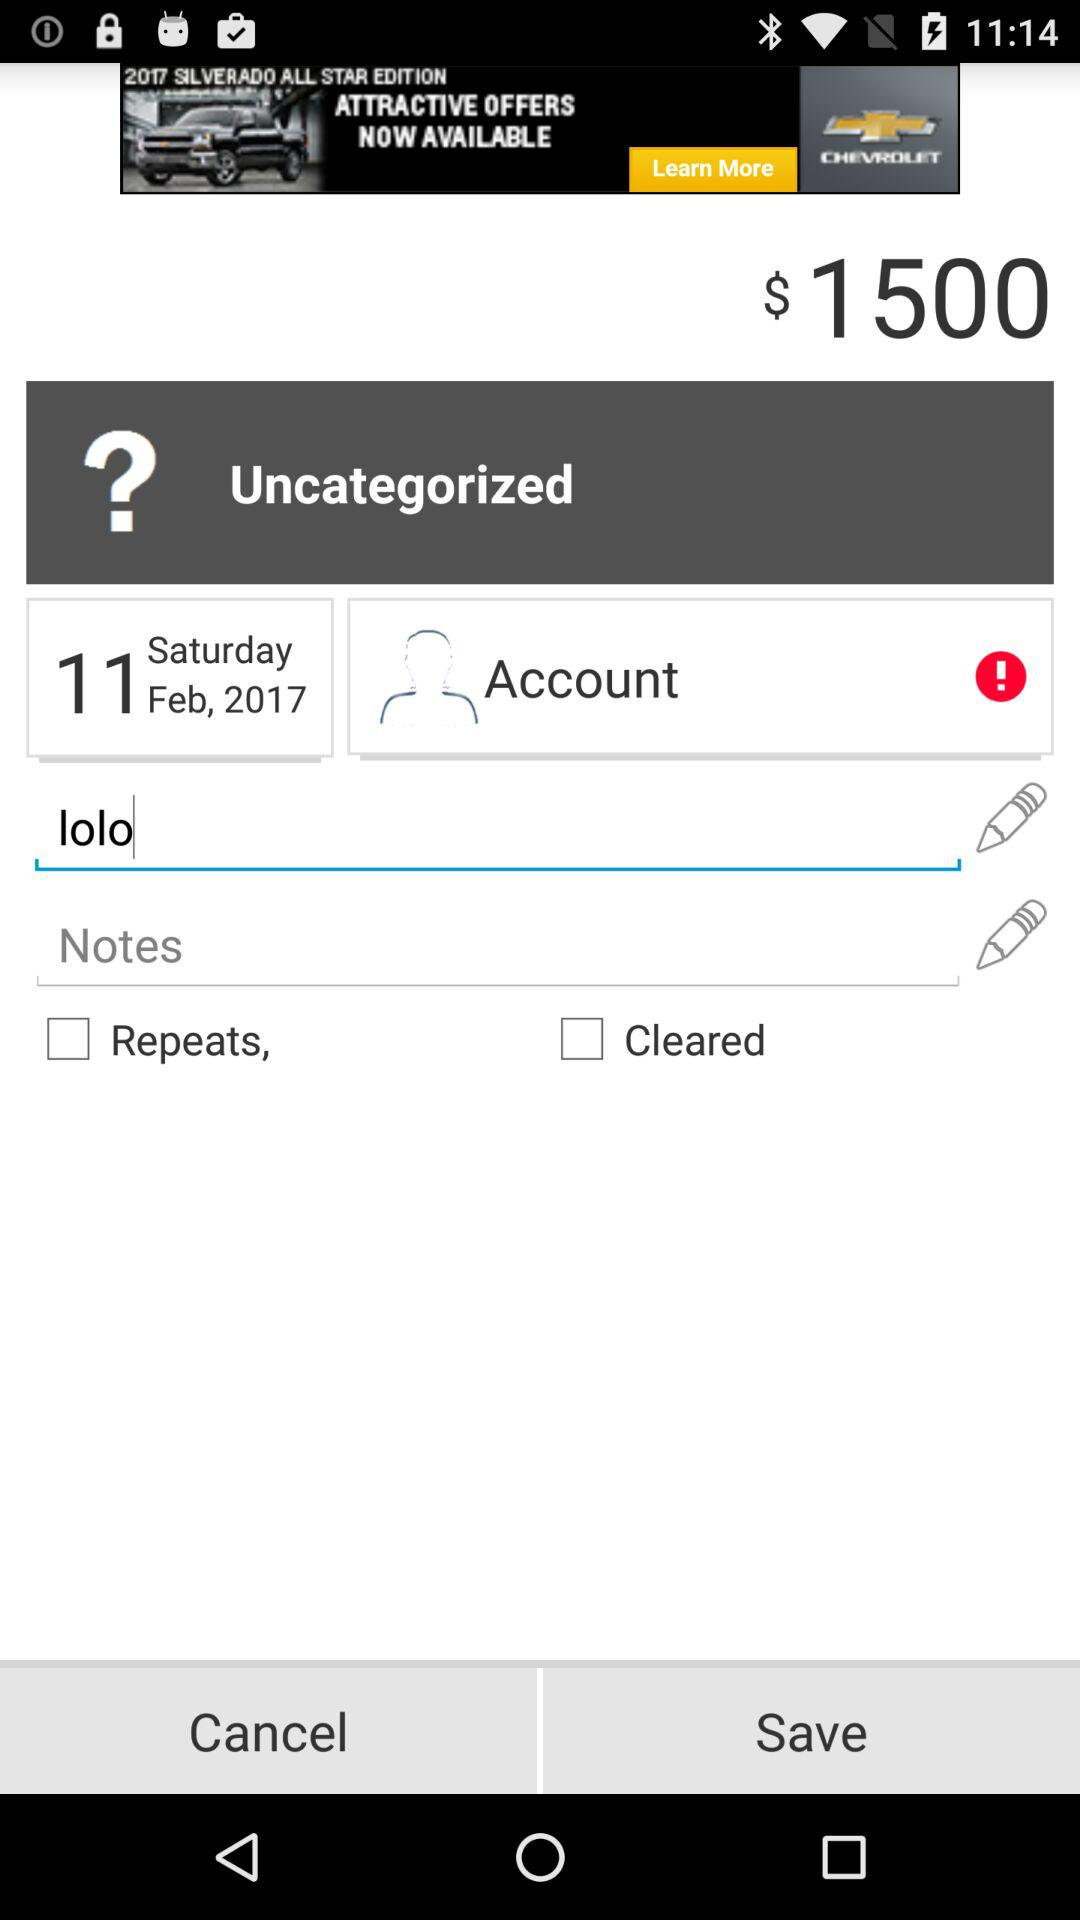What is the date of the transaction?
Answer the question using a single word or phrase. Saturday Feb, 2017 